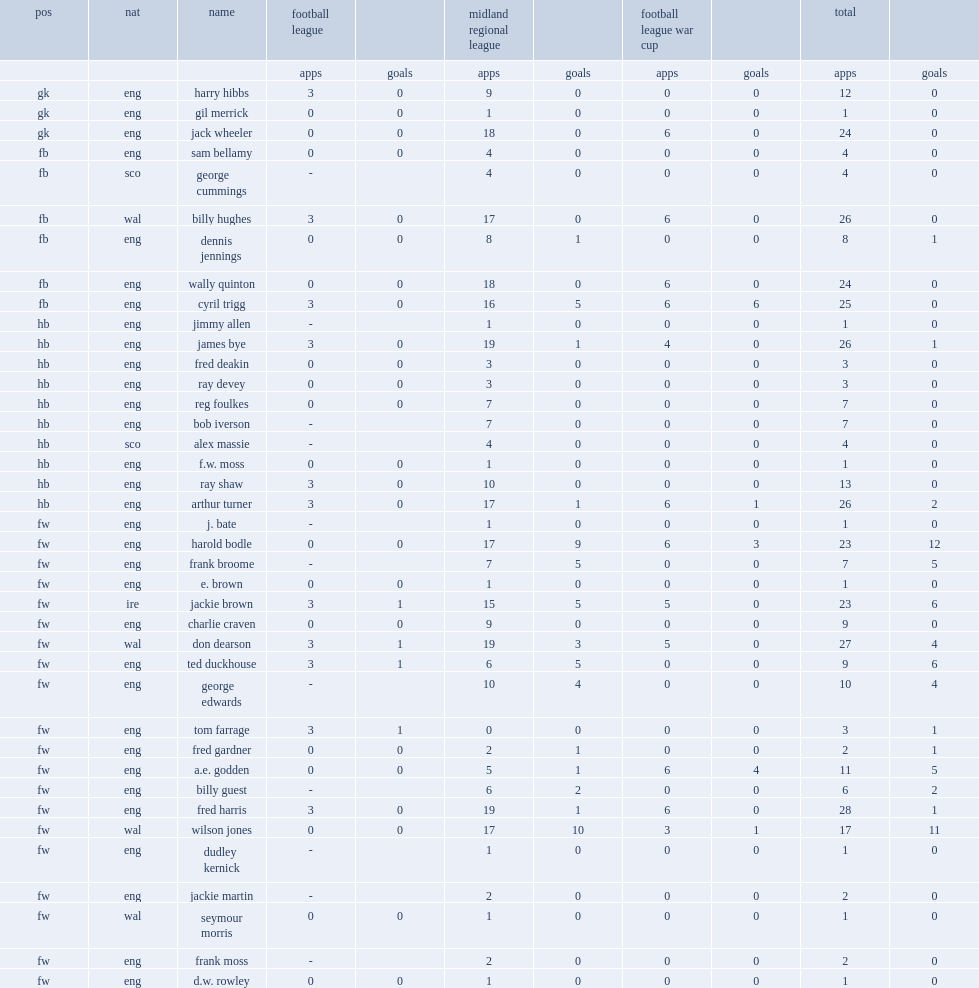List the matches that birmingham played in. Midland regional league football league war cup. 